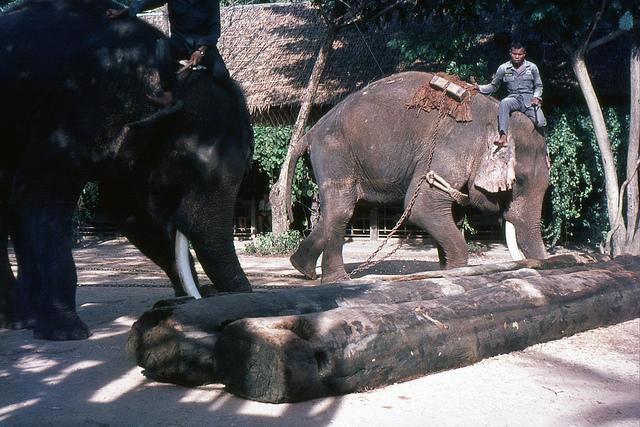How many elephants are there?
Give a very brief answer. 2. How many people are visible?
Give a very brief answer. 2. 